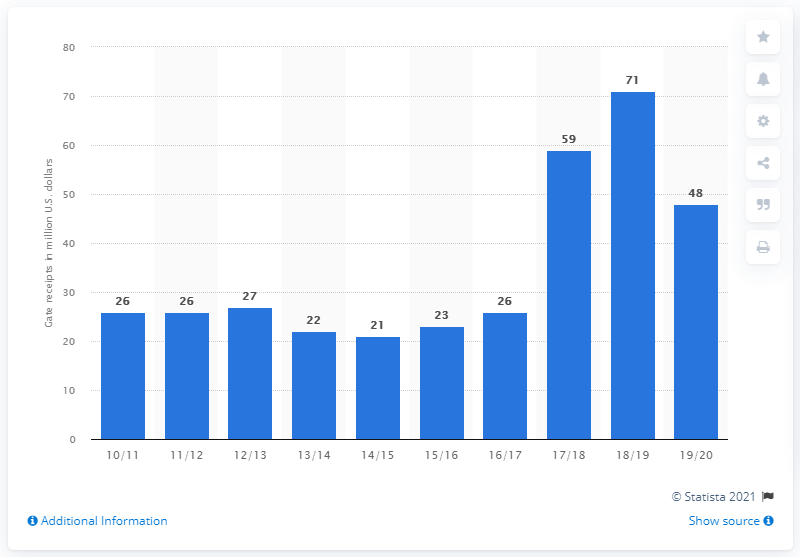Draw attention to some important aspects in this diagram. The gate receipts of the 76ers in the 2019/20 season were approximately 48 dollars. 